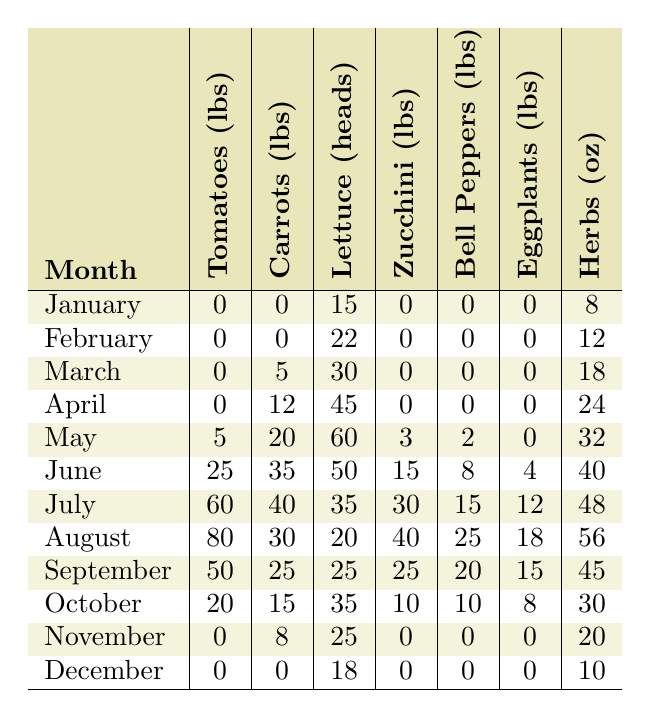What is the highest yield of tomatoes, and in which month did it occur? The highest yield of tomatoes is 80 lbs, which is found in August.
Answer: 80 lbs in August How many total pounds of carrots were yielded from January to March? Adding the yields from January (0 lbs), February (0 lbs), and March (5 lbs) gives a total of 0 + 0 + 5 = 5 lbs.
Answer: 5 lbs Did the community garden produce any zucchini in the winter months (December to February)? Looking at the records for December (0 lbs), January (0 lbs), and February (0 lbs), there was no zucchini produced in these months.
Answer: No What was the average number of heads of lettuce produced from the community garden from May to August? The yields of lettuce from May (60 heads), June (50 heads), July (35 heads), and August (20 heads) sum up to 60 + 50 + 35 + 20 = 165 heads. There are 4 months, so the average is 165 / 4 = 41.25 heads.
Answer: 41.25 heads In which month did eggplant yield meet its maximum, and what was the total yield that month? The maximum yield for eggplants is 12 lbs, which occurred in July.
Answer: 12 lbs in July What is the total yield of herbs for the entire year? Summing the monthly yields gives: 8 + 12 + 18 + 24 + 32 + 40 + 48 + 56 + 45 + 30 + 20 + 10 =  373 oz.
Answer: 373 oz Was there any month when both tomatoes and bell peppers yields reached their maximum simultaneously? The maximum for tomatoes is 80 lbs in August, and the maximum for bell peppers is 25 lbs also in August; thus, yes, both peaked in August.
Answer: Yes What is the difference in yield of zucchini between June and July? The yield for zucchini in June is 15 lbs, and in July it is 30 lbs, so the difference is 30 - 15 = 15 lbs.
Answer: 15 lbs How many months had a yield of carrots less than 10 lbs? The months of January (0 lbs), February (0 lbs), and March (5 lbs) had yields of carrots less than 10 lbs, totaling 3 months.
Answer: 3 months Was there any month where the herb yield surpassed the eggplant yield? In the months of June (40 oz), July (48 oz), August (56 oz), and September (45 oz), herb yields surpassed the eggplant yield.
Answer: Yes 